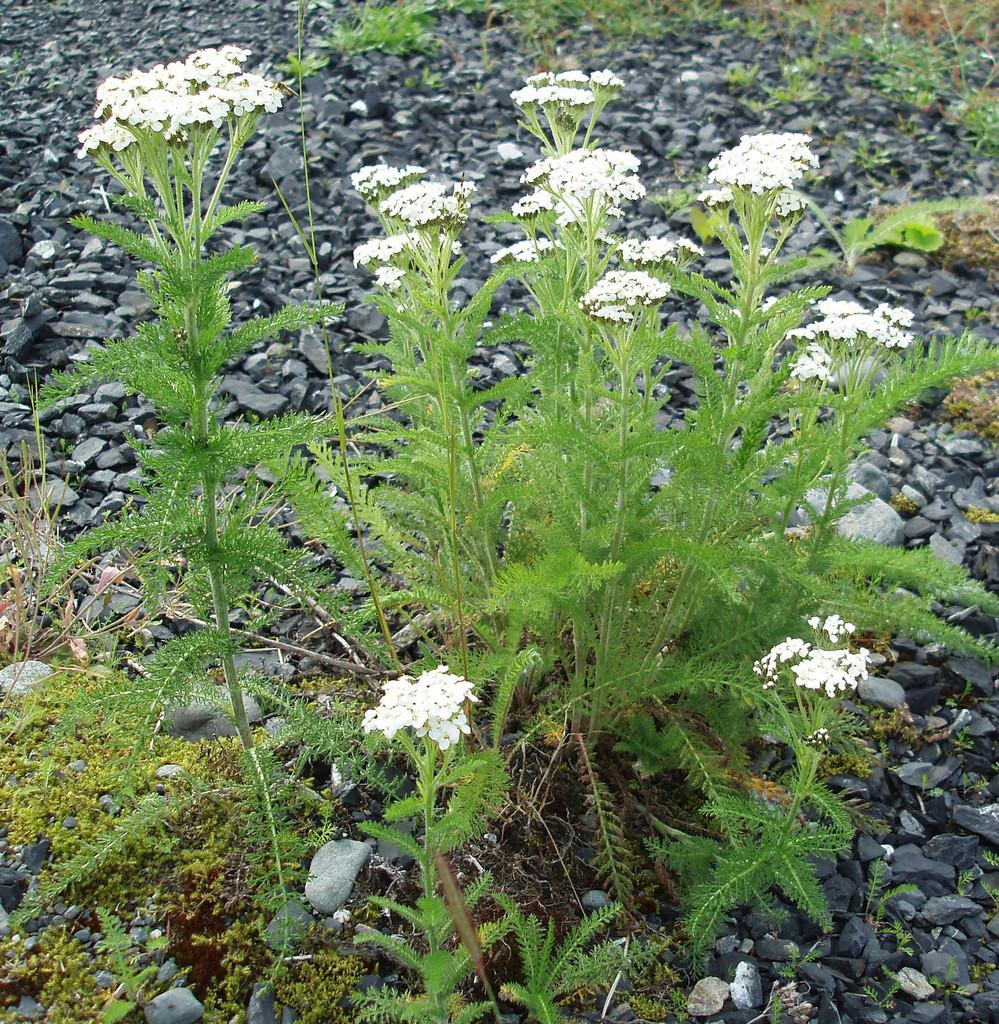What types of living organisms can be seen in the image? Plants and flowers are visible in the image. What other objects can be seen in the image besides plants and flowers? There are stones in the image. What type of creature is using the kettle in the image? There is no creature or kettle present in the image. 